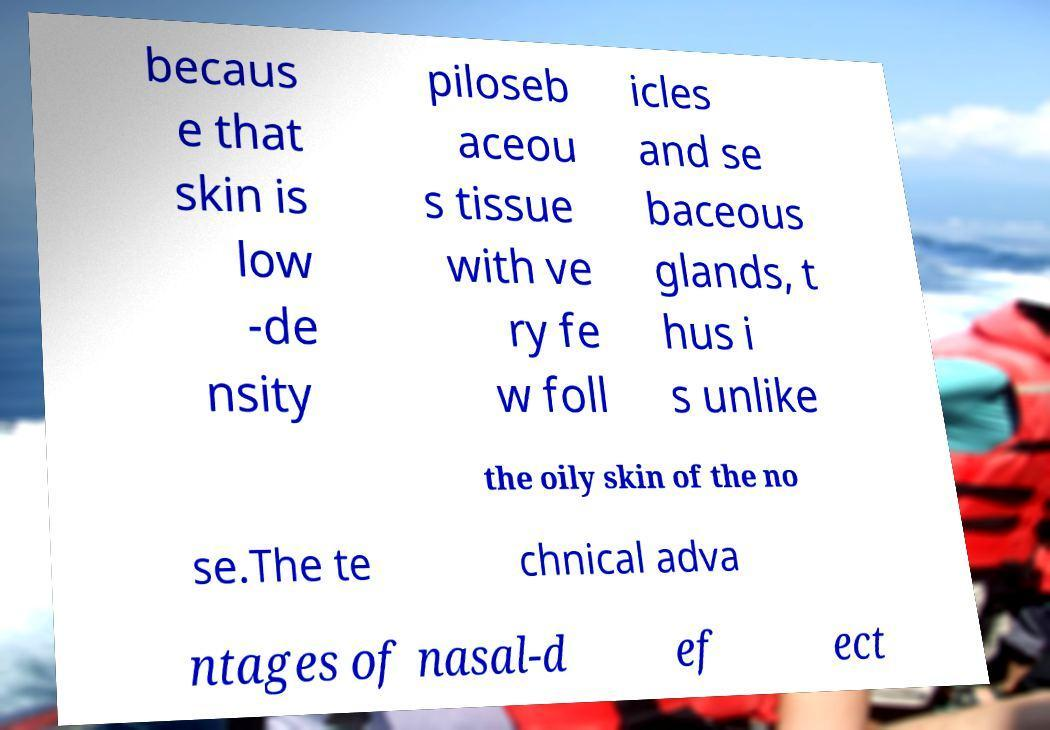Can you read and provide the text displayed in the image?This photo seems to have some interesting text. Can you extract and type it out for me? becaus e that skin is low -de nsity piloseb aceou s tissue with ve ry fe w foll icles and se baceous glands, t hus i s unlike the oily skin of the no se.The te chnical adva ntages of nasal-d ef ect 